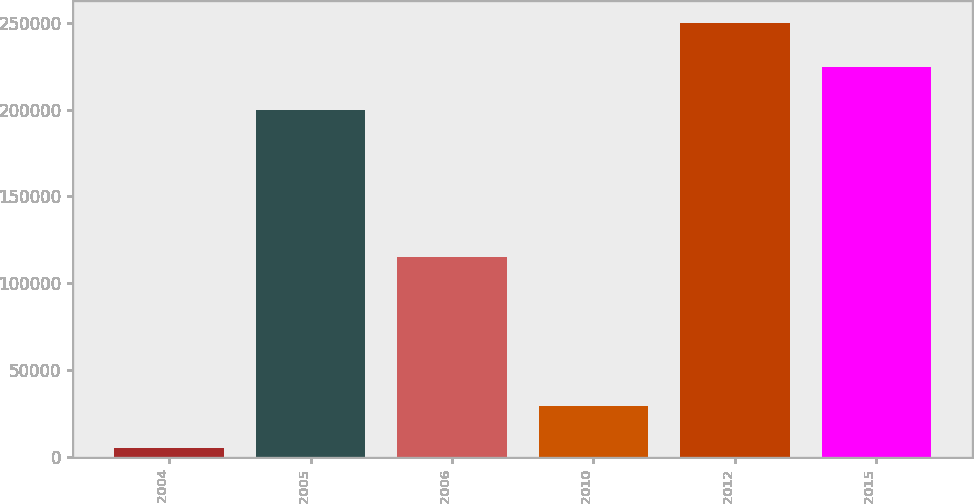Convert chart to OTSL. <chart><loc_0><loc_0><loc_500><loc_500><bar_chart><fcel>2004<fcel>2005<fcel>2006<fcel>2010<fcel>2012<fcel>2015<nl><fcel>5000<fcel>200000<fcel>115000<fcel>29500<fcel>250000<fcel>224500<nl></chart> 